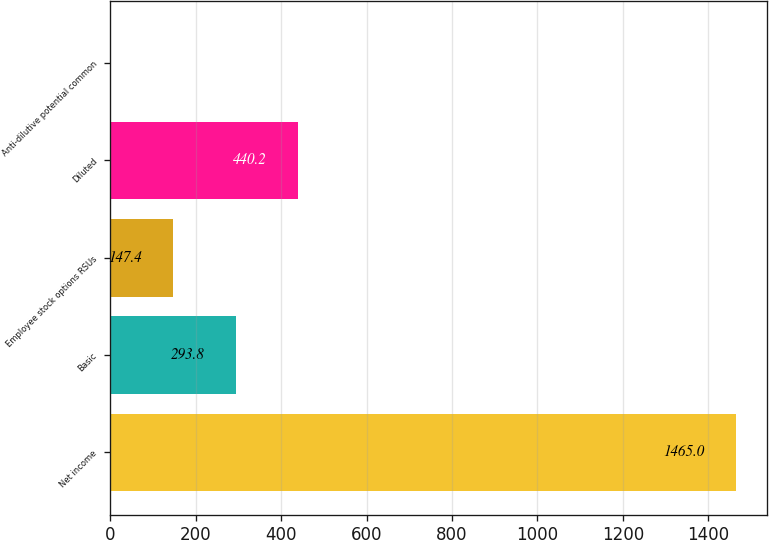Convert chart. <chart><loc_0><loc_0><loc_500><loc_500><bar_chart><fcel>Net income<fcel>Basic<fcel>Employee stock options RSUs<fcel>Diluted<fcel>Anti-dilutive potential common<nl><fcel>1465<fcel>293.8<fcel>147.4<fcel>440.2<fcel>1<nl></chart> 